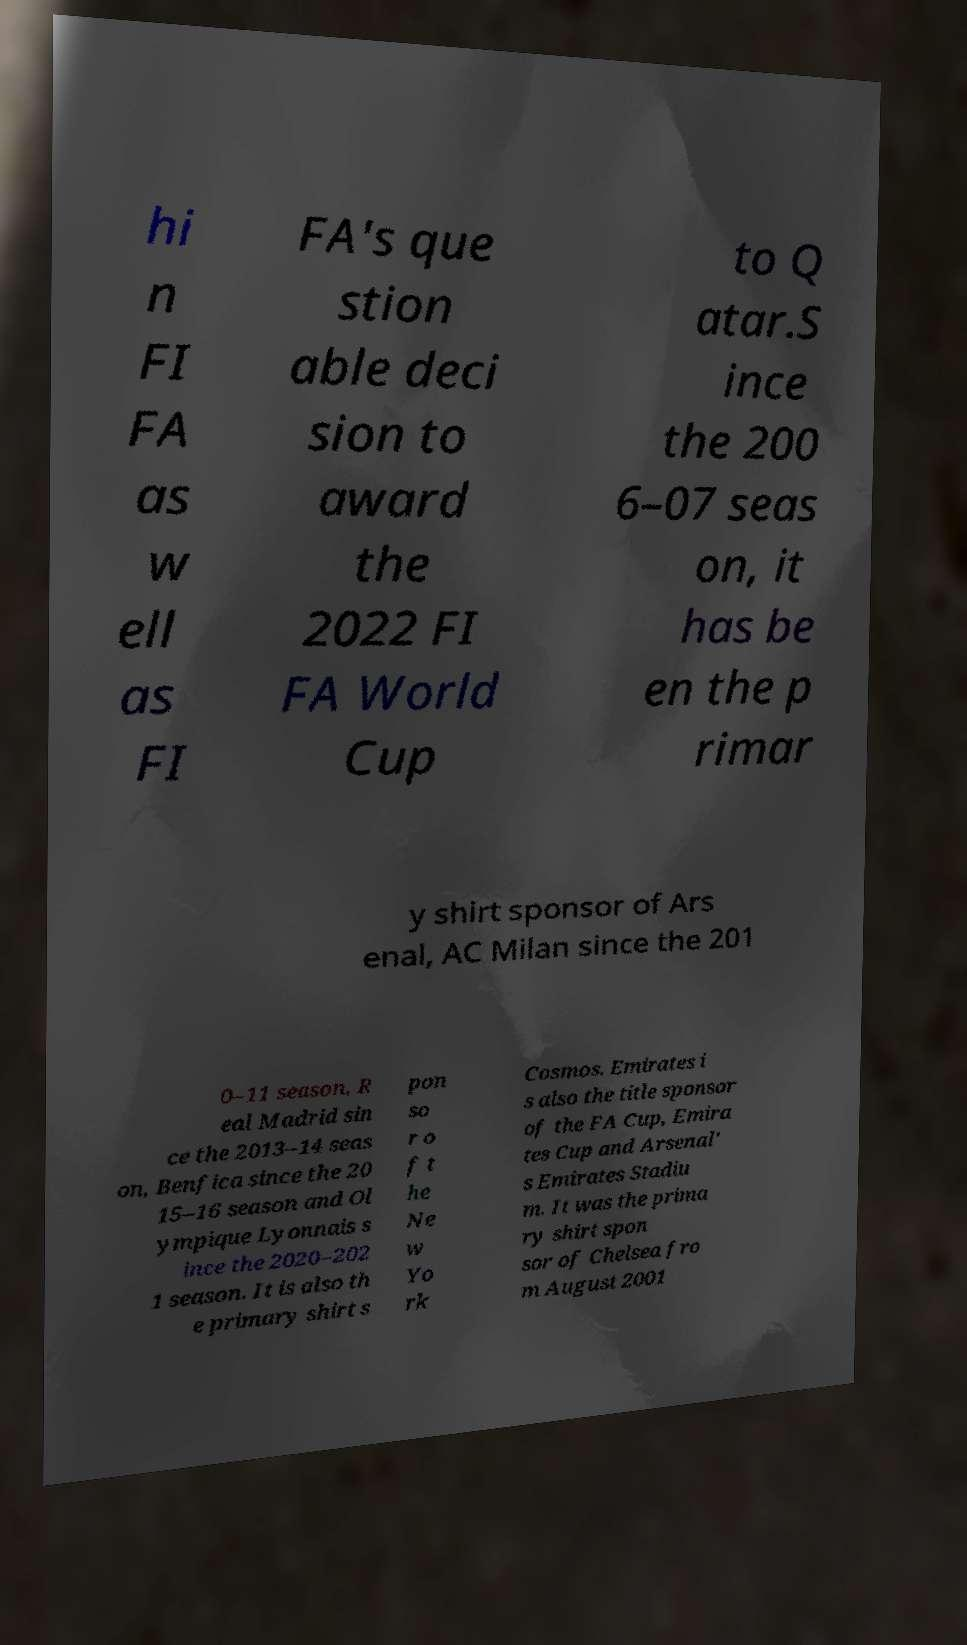What messages or text are displayed in this image? I need them in a readable, typed format. hi n FI FA as w ell as FI FA's que stion able deci sion to award the 2022 FI FA World Cup to Q atar.S ince the 200 6–07 seas on, it has be en the p rimar y shirt sponsor of Ars enal, AC Milan since the 201 0–11 season, R eal Madrid sin ce the 2013–14 seas on, Benfica since the 20 15–16 season and Ol ympique Lyonnais s ince the 2020–202 1 season. It is also th e primary shirt s pon so r o f t he Ne w Yo rk Cosmos. Emirates i s also the title sponsor of the FA Cup, Emira tes Cup and Arsenal' s Emirates Stadiu m. It was the prima ry shirt spon sor of Chelsea fro m August 2001 